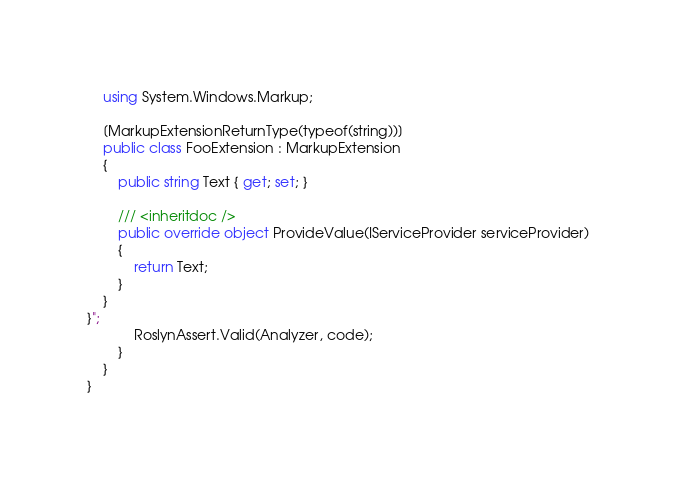Convert code to text. <code><loc_0><loc_0><loc_500><loc_500><_C#_>    using System.Windows.Markup;

    [MarkupExtensionReturnType(typeof(string))]
    public class FooExtension : MarkupExtension
    {
        public string Text { get; set; }

        /// <inheritdoc />
        public override object ProvideValue(IServiceProvider serviceProvider)
        {
            return Text;
        }
    }
}";
            RoslynAssert.Valid(Analyzer, code);
        }
    }
}
</code> 